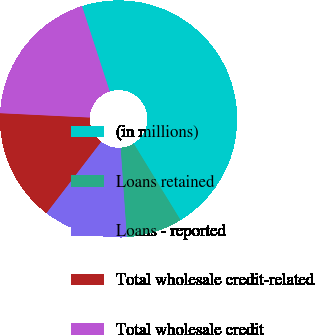<chart> <loc_0><loc_0><loc_500><loc_500><pie_chart><fcel>(in millions)<fcel>Loans retained<fcel>Loans - reported<fcel>Total wholesale credit-related<fcel>Total wholesale credit<nl><fcel>46.26%<fcel>7.64%<fcel>11.51%<fcel>15.37%<fcel>19.23%<nl></chart> 